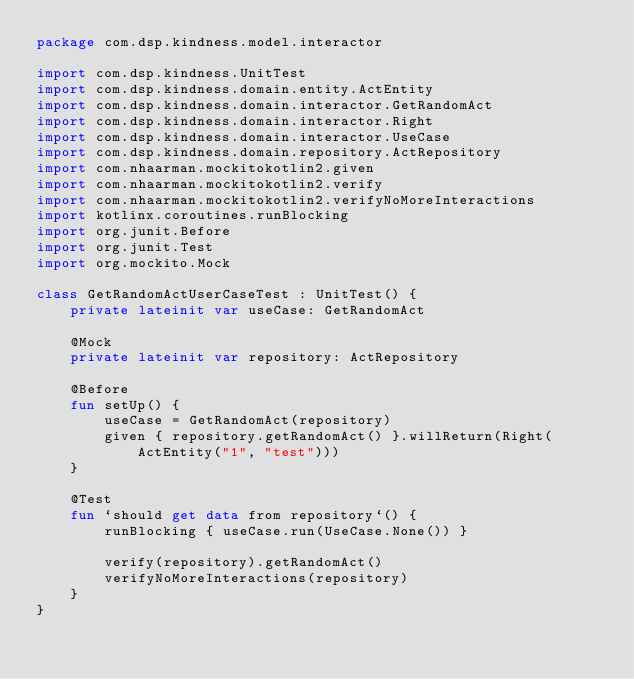Convert code to text. <code><loc_0><loc_0><loc_500><loc_500><_Kotlin_>package com.dsp.kindness.model.interactor

import com.dsp.kindness.UnitTest
import com.dsp.kindness.domain.entity.ActEntity
import com.dsp.kindness.domain.interactor.GetRandomAct
import com.dsp.kindness.domain.interactor.Right
import com.dsp.kindness.domain.interactor.UseCase
import com.dsp.kindness.domain.repository.ActRepository
import com.nhaarman.mockitokotlin2.given
import com.nhaarman.mockitokotlin2.verify
import com.nhaarman.mockitokotlin2.verifyNoMoreInteractions
import kotlinx.coroutines.runBlocking
import org.junit.Before
import org.junit.Test
import org.mockito.Mock

class GetRandomActUserCaseTest : UnitTest() {
    private lateinit var useCase: GetRandomAct

    @Mock
    private lateinit var repository: ActRepository

    @Before
    fun setUp() {
        useCase = GetRandomAct(repository)
        given { repository.getRandomAct() }.willReturn(Right(ActEntity("1", "test")))
    }

    @Test
    fun `should get data from repository`() {
        runBlocking { useCase.run(UseCase.None()) }

        verify(repository).getRandomAct()
        verifyNoMoreInteractions(repository)
    }
}
</code> 